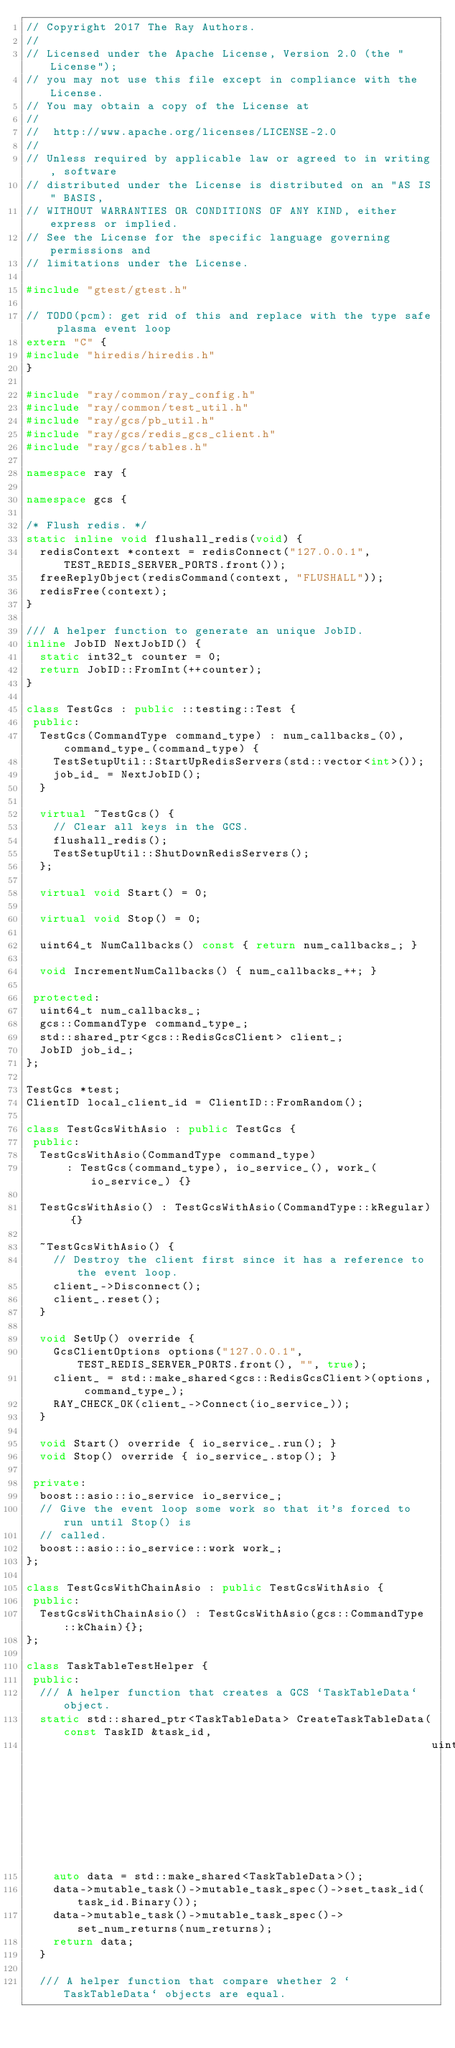<code> <loc_0><loc_0><loc_500><loc_500><_C++_>// Copyright 2017 The Ray Authors.
//
// Licensed under the Apache License, Version 2.0 (the "License");
// you may not use this file except in compliance with the License.
// You may obtain a copy of the License at
//
//  http://www.apache.org/licenses/LICENSE-2.0
//
// Unless required by applicable law or agreed to in writing, software
// distributed under the License is distributed on an "AS IS" BASIS,
// WITHOUT WARRANTIES OR CONDITIONS OF ANY KIND, either express or implied.
// See the License for the specific language governing permissions and
// limitations under the License.

#include "gtest/gtest.h"

// TODO(pcm): get rid of this and replace with the type safe plasma event loop
extern "C" {
#include "hiredis/hiredis.h"
}

#include "ray/common/ray_config.h"
#include "ray/common/test_util.h"
#include "ray/gcs/pb_util.h"
#include "ray/gcs/redis_gcs_client.h"
#include "ray/gcs/tables.h"

namespace ray {

namespace gcs {

/* Flush redis. */
static inline void flushall_redis(void) {
  redisContext *context = redisConnect("127.0.0.1", TEST_REDIS_SERVER_PORTS.front());
  freeReplyObject(redisCommand(context, "FLUSHALL"));
  redisFree(context);
}

/// A helper function to generate an unique JobID.
inline JobID NextJobID() {
  static int32_t counter = 0;
  return JobID::FromInt(++counter);
}

class TestGcs : public ::testing::Test {
 public:
  TestGcs(CommandType command_type) : num_callbacks_(0), command_type_(command_type) {
    TestSetupUtil::StartUpRedisServers(std::vector<int>());
    job_id_ = NextJobID();
  }

  virtual ~TestGcs() {
    // Clear all keys in the GCS.
    flushall_redis();
    TestSetupUtil::ShutDownRedisServers();
  };

  virtual void Start() = 0;

  virtual void Stop() = 0;

  uint64_t NumCallbacks() const { return num_callbacks_; }

  void IncrementNumCallbacks() { num_callbacks_++; }

 protected:
  uint64_t num_callbacks_;
  gcs::CommandType command_type_;
  std::shared_ptr<gcs::RedisGcsClient> client_;
  JobID job_id_;
};

TestGcs *test;
ClientID local_client_id = ClientID::FromRandom();

class TestGcsWithAsio : public TestGcs {
 public:
  TestGcsWithAsio(CommandType command_type)
      : TestGcs(command_type), io_service_(), work_(io_service_) {}

  TestGcsWithAsio() : TestGcsWithAsio(CommandType::kRegular) {}

  ~TestGcsWithAsio() {
    // Destroy the client first since it has a reference to the event loop.
    client_->Disconnect();
    client_.reset();
  }

  void SetUp() override {
    GcsClientOptions options("127.0.0.1", TEST_REDIS_SERVER_PORTS.front(), "", true);
    client_ = std::make_shared<gcs::RedisGcsClient>(options, command_type_);
    RAY_CHECK_OK(client_->Connect(io_service_));
  }

  void Start() override { io_service_.run(); }
  void Stop() override { io_service_.stop(); }

 private:
  boost::asio::io_service io_service_;
  // Give the event loop some work so that it's forced to run until Stop() is
  // called.
  boost::asio::io_service::work work_;
};

class TestGcsWithChainAsio : public TestGcsWithAsio {
 public:
  TestGcsWithChainAsio() : TestGcsWithAsio(gcs::CommandType::kChain){};
};

class TaskTableTestHelper {
 public:
  /// A helper function that creates a GCS `TaskTableData` object.
  static std::shared_ptr<TaskTableData> CreateTaskTableData(const TaskID &task_id,
                                                            uint64_t num_returns = 0) {
    auto data = std::make_shared<TaskTableData>();
    data->mutable_task()->mutable_task_spec()->set_task_id(task_id.Binary());
    data->mutable_task()->mutable_task_spec()->set_num_returns(num_returns);
    return data;
  }

  /// A helper function that compare whether 2 `TaskTableData` objects are equal.</code> 